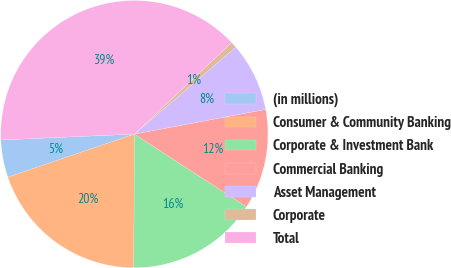Convert chart to OTSL. <chart><loc_0><loc_0><loc_500><loc_500><pie_chart><fcel>(in millions)<fcel>Consumer & Community Banking<fcel>Corporate & Investment Bank<fcel>Commercial Banking<fcel>Asset Management<fcel>Corporate<fcel>Total<nl><fcel>4.53%<fcel>19.71%<fcel>15.91%<fcel>12.12%<fcel>8.32%<fcel>0.73%<fcel>38.69%<nl></chart> 